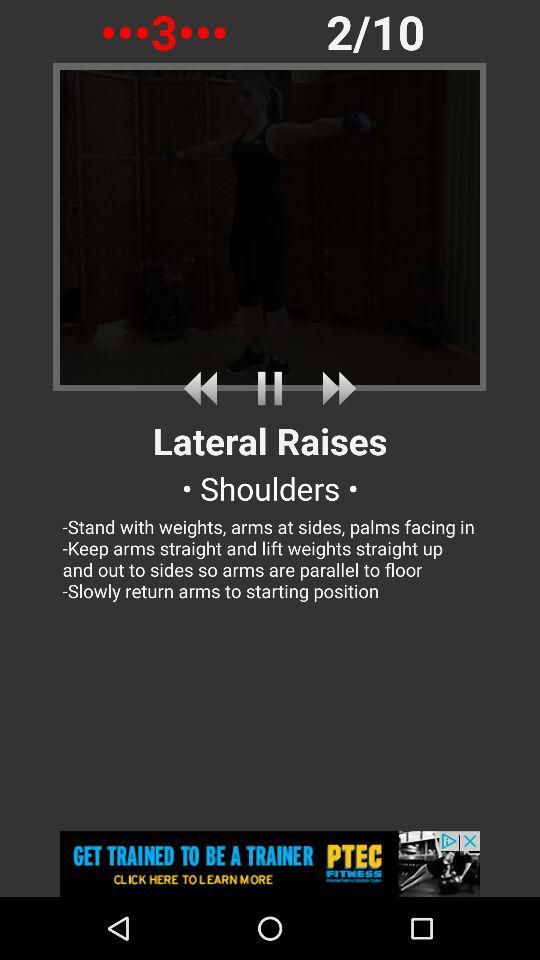How many more steps are there until the end of this workout?
Answer the question using a single word or phrase. 8 